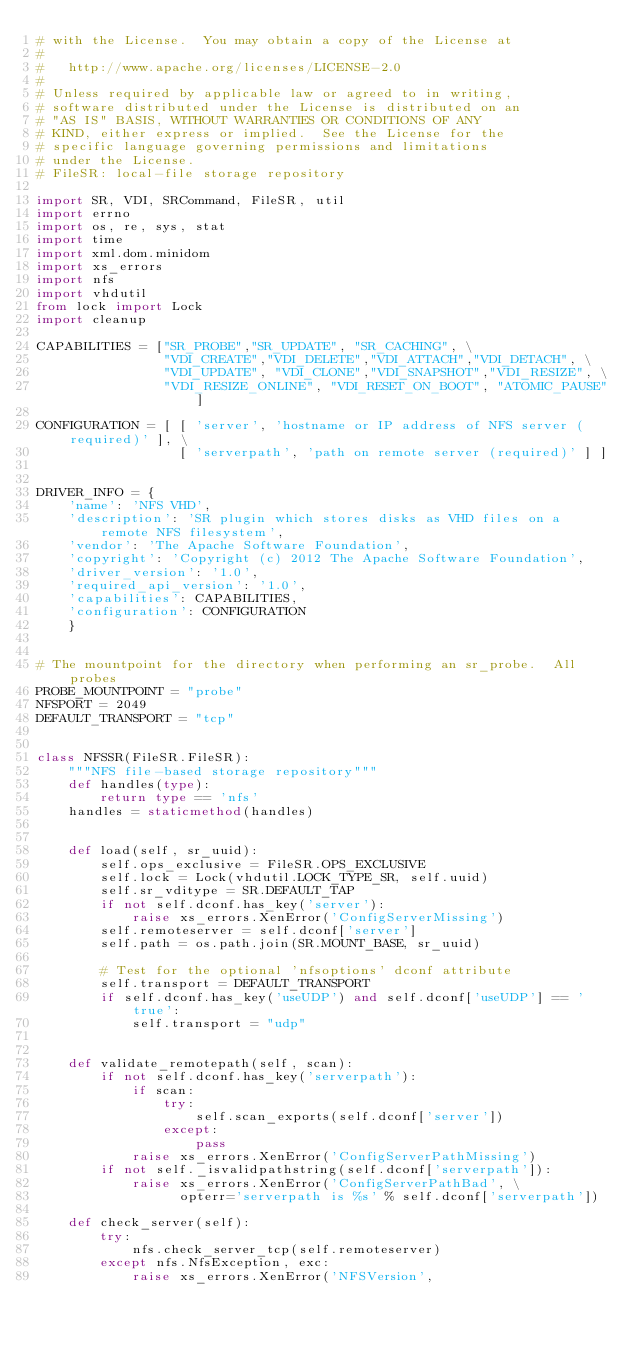Convert code to text. <code><loc_0><loc_0><loc_500><loc_500><_Python_># with the License.  You may obtain a copy of the License at
#
#   http://www.apache.org/licenses/LICENSE-2.0
#
# Unless required by applicable law or agreed to in writing,
# software distributed under the License is distributed on an
# "AS IS" BASIS, WITHOUT WARRANTIES OR CONDITIONS OF ANY
# KIND, either express or implied.  See the License for the
# specific language governing permissions and limitations
# under the License.
# FileSR: local-file storage repository

import SR, VDI, SRCommand, FileSR, util
import errno
import os, re, sys, stat
import time
import xml.dom.minidom
import xs_errors
import nfs
import vhdutil
from lock import Lock
import cleanup

CAPABILITIES = ["SR_PROBE","SR_UPDATE", "SR_CACHING", \
                "VDI_CREATE","VDI_DELETE","VDI_ATTACH","VDI_DETACH", \
                "VDI_UPDATE", "VDI_CLONE","VDI_SNAPSHOT","VDI_RESIZE", \
                "VDI_RESIZE_ONLINE", "VDI_RESET_ON_BOOT", "ATOMIC_PAUSE"]

CONFIGURATION = [ [ 'server', 'hostname or IP address of NFS server (required)' ], \
                  [ 'serverpath', 'path on remote server (required)' ] ]


DRIVER_INFO = {
    'name': 'NFS VHD',
    'description': 'SR plugin which stores disks as VHD files on a remote NFS filesystem',
    'vendor': 'The Apache Software Foundation',
    'copyright': 'Copyright (c) 2012 The Apache Software Foundation',
    'driver_version': '1.0',
    'required_api_version': '1.0',
    'capabilities': CAPABILITIES,
    'configuration': CONFIGURATION
    }


# The mountpoint for the directory when performing an sr_probe.  All probes
PROBE_MOUNTPOINT = "probe"
NFSPORT = 2049
DEFAULT_TRANSPORT = "tcp"


class NFSSR(FileSR.FileSR):
    """NFS file-based storage repository"""
    def handles(type):
        return type == 'nfs'
    handles = staticmethod(handles)


    def load(self, sr_uuid):
        self.ops_exclusive = FileSR.OPS_EXCLUSIVE
        self.lock = Lock(vhdutil.LOCK_TYPE_SR, self.uuid)
        self.sr_vditype = SR.DEFAULT_TAP
        if not self.dconf.has_key('server'):
            raise xs_errors.XenError('ConfigServerMissing')
        self.remoteserver = self.dconf['server']
        self.path = os.path.join(SR.MOUNT_BASE, sr_uuid)

        # Test for the optional 'nfsoptions' dconf attribute
        self.transport = DEFAULT_TRANSPORT
        if self.dconf.has_key('useUDP') and self.dconf['useUDP'] == 'true':
            self.transport = "udp"


    def validate_remotepath(self, scan):
        if not self.dconf.has_key('serverpath'):
            if scan:
                try:
                    self.scan_exports(self.dconf['server'])
                except:
                    pass
            raise xs_errors.XenError('ConfigServerPathMissing')
        if not self._isvalidpathstring(self.dconf['serverpath']):
            raise xs_errors.XenError('ConfigServerPathBad', \
                  opterr='serverpath is %s' % self.dconf['serverpath'])

    def check_server(self):
        try:
            nfs.check_server_tcp(self.remoteserver)
        except nfs.NfsException, exc:
            raise xs_errors.XenError('NFSVersion',</code> 